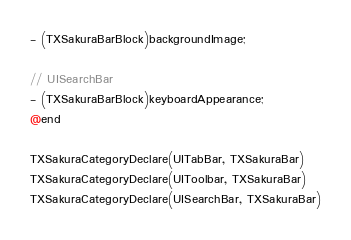Convert code to text. <code><loc_0><loc_0><loc_500><loc_500><_C_>- (TXSakuraBarBlock)backgroundImage;

// UISearchBar
- (TXSakuraBarBlock)keyboardAppearance;
@end

TXSakuraCategoryDeclare(UITabBar, TXSakuraBar)
TXSakuraCategoryDeclare(UIToolbar, TXSakuraBar)
TXSakuraCategoryDeclare(UISearchBar, TXSakuraBar)
</code> 